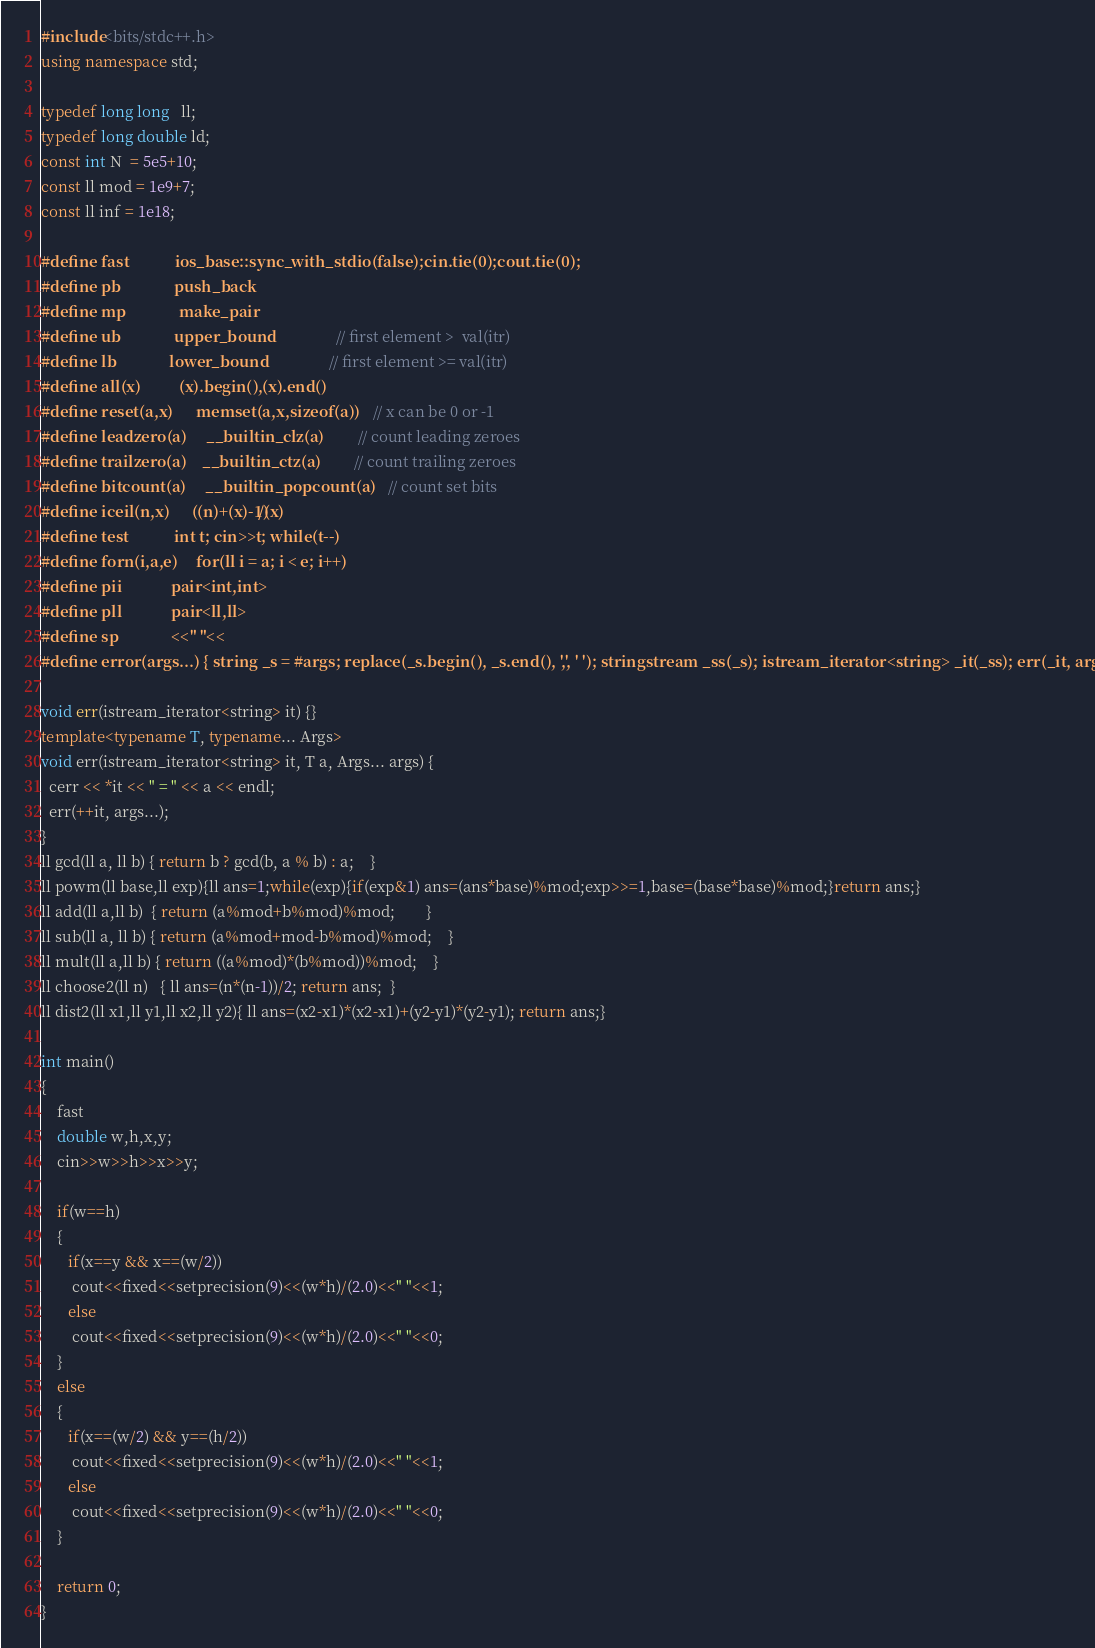Convert code to text. <code><loc_0><loc_0><loc_500><loc_500><_C++_>#include<bits/stdc++.h>
using namespace std;
 
typedef long long   ll;
typedef long double ld;
const int N  = 5e5+10;
const ll mod = 1e9+7;
const ll inf = 1e18;
 
#define fast            ios_base::sync_with_stdio(false);cin.tie(0);cout.tie(0);
#define pb              push_back
#define mp              make_pair
#define ub              upper_bound                 // first element >  val(itr)
#define lb              lower_bound                 // first element >= val(itr) 
#define all(x)          (x).begin(),(x).end()
#define reset(a,x)      memset(a,x,sizeof(a))       // x can be 0 or -1
#define leadzero(a)     __builtin_clz(a)            // count leading zeroes
#define trailzero(a)    __builtin_ctz(a)            // count trailing zeroes
#define bitcount(a)     __builtin_popcount(a)       // count set bits
#define iceil(n,x)      ((n)+(x)-1)/(x)
#define test            int t; cin>>t; while(t--)
#define forn(i,a,e)     for(ll i = a; i < e; i++)
#define pii             pair<int,int>
#define pll             pair<ll,ll>
#define sp              <<" "<<
#define error(args...) { string _s = #args; replace(_s.begin(), _s.end(), ',', ' '); stringstream _ss(_s); istream_iterator<string> _it(_ss); err(_it, args); }

void err(istream_iterator<string> it) {}
template<typename T, typename... Args>
void err(istream_iterator<string> it, T a, Args... args) {
  cerr << *it << " = " << a << endl;
  err(++it, args...);
}
ll gcd(ll a, ll b) { return b ? gcd(b, a % b) : a;    }
ll powm(ll base,ll exp){ll ans=1;while(exp){if(exp&1) ans=(ans*base)%mod;exp>>=1,base=(base*base)%mod;}return ans;}
ll add(ll a,ll b)  { return (a%mod+b%mod)%mod;        }
ll sub(ll a, ll b) { return (a%mod+mod-b%mod)%mod;    }
ll mult(ll a,ll b) { return ((a%mod)*(b%mod))%mod;    }
ll choose2(ll n)   { ll ans=(n*(n-1))/2; return ans;  }
ll dist2(ll x1,ll y1,ll x2,ll y2){ ll ans=(x2-x1)*(x2-x1)+(y2-y1)*(y2-y1); return ans;}

int main()
{
    fast
    double w,h,x,y;
    cin>>w>>h>>x>>y;

    if(w==h)
    {
       if(x==y && x==(w/2))
        cout<<fixed<<setprecision(9)<<(w*h)/(2.0)<<" "<<1;
       else
        cout<<fixed<<setprecision(9)<<(w*h)/(2.0)<<" "<<0;
    }
    else
    {
       if(x==(w/2) && y==(h/2))
        cout<<fixed<<setprecision(9)<<(w*h)/(2.0)<<" "<<1;
       else
        cout<<fixed<<setprecision(9)<<(w*h)/(2.0)<<" "<<0;
    }

    return 0;
}</code> 